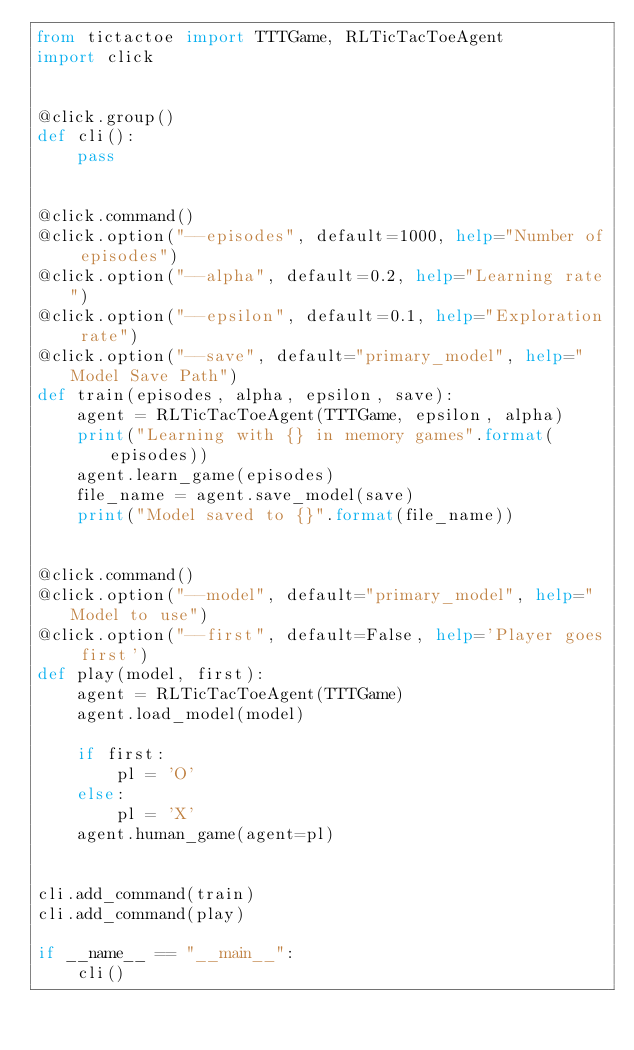Convert code to text. <code><loc_0><loc_0><loc_500><loc_500><_Python_>from tictactoe import TTTGame, RLTicTacToeAgent
import click


@click.group()
def cli():
    pass


@click.command()
@click.option("--episodes", default=1000, help="Number of episodes")
@click.option("--alpha", default=0.2, help="Learning rate")
@click.option("--epsilon", default=0.1, help="Exploration rate")
@click.option("--save", default="primary_model", help="Model Save Path")
def train(episodes, alpha, epsilon, save):
    agent = RLTicTacToeAgent(TTTGame, epsilon, alpha)
    print("Learning with {} in memory games".format(episodes))
    agent.learn_game(episodes)
    file_name = agent.save_model(save)
    print("Model saved to {}".format(file_name))


@click.command()
@click.option("--model", default="primary_model", help="Model to use")
@click.option("--first", default=False, help='Player goes first')
def play(model, first):
    agent = RLTicTacToeAgent(TTTGame)
    agent.load_model(model)

    if first:
        pl = 'O'
    else:
        pl = 'X'
    agent.human_game(agent=pl)


cli.add_command(train)
cli.add_command(play)

if __name__ == "__main__":
    cli()
</code> 